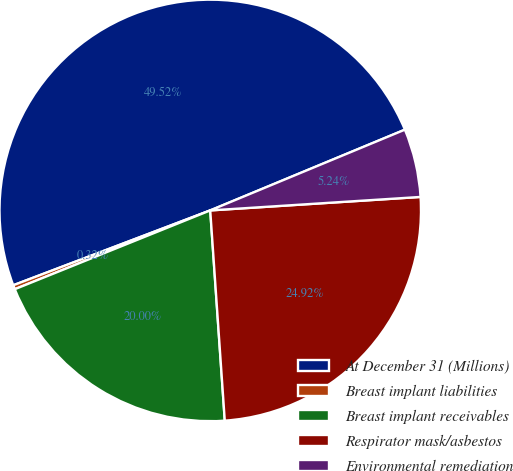<chart> <loc_0><loc_0><loc_500><loc_500><pie_chart><fcel>At December 31 (Millions)<fcel>Breast implant liabilities<fcel>Breast implant receivables<fcel>Respirator mask/asbestos<fcel>Environmental remediation<nl><fcel>49.52%<fcel>0.32%<fcel>20.0%<fcel>24.92%<fcel>5.24%<nl></chart> 